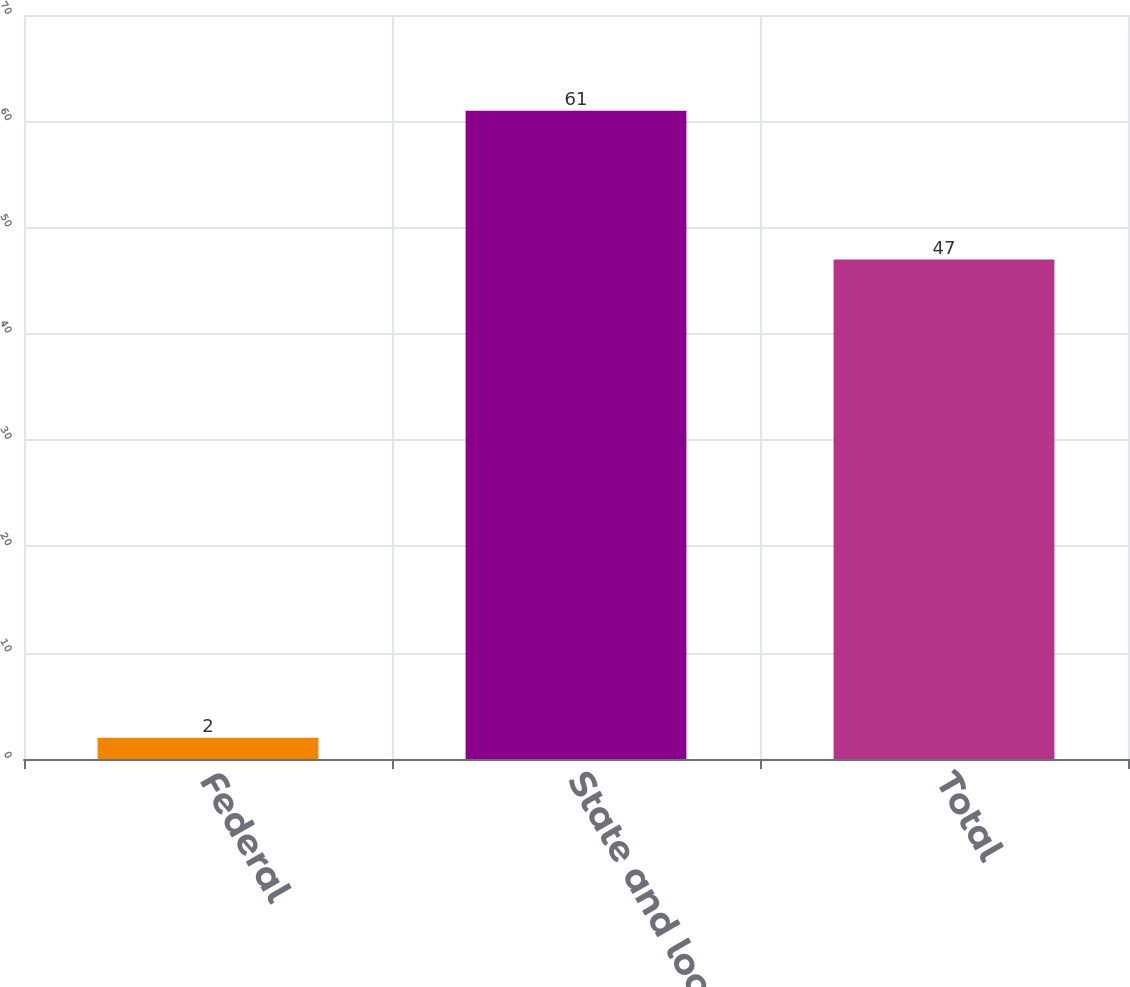Convert chart to OTSL. <chart><loc_0><loc_0><loc_500><loc_500><bar_chart><fcel>Federal<fcel>State and local<fcel>Total<nl><fcel>2<fcel>61<fcel>47<nl></chart> 